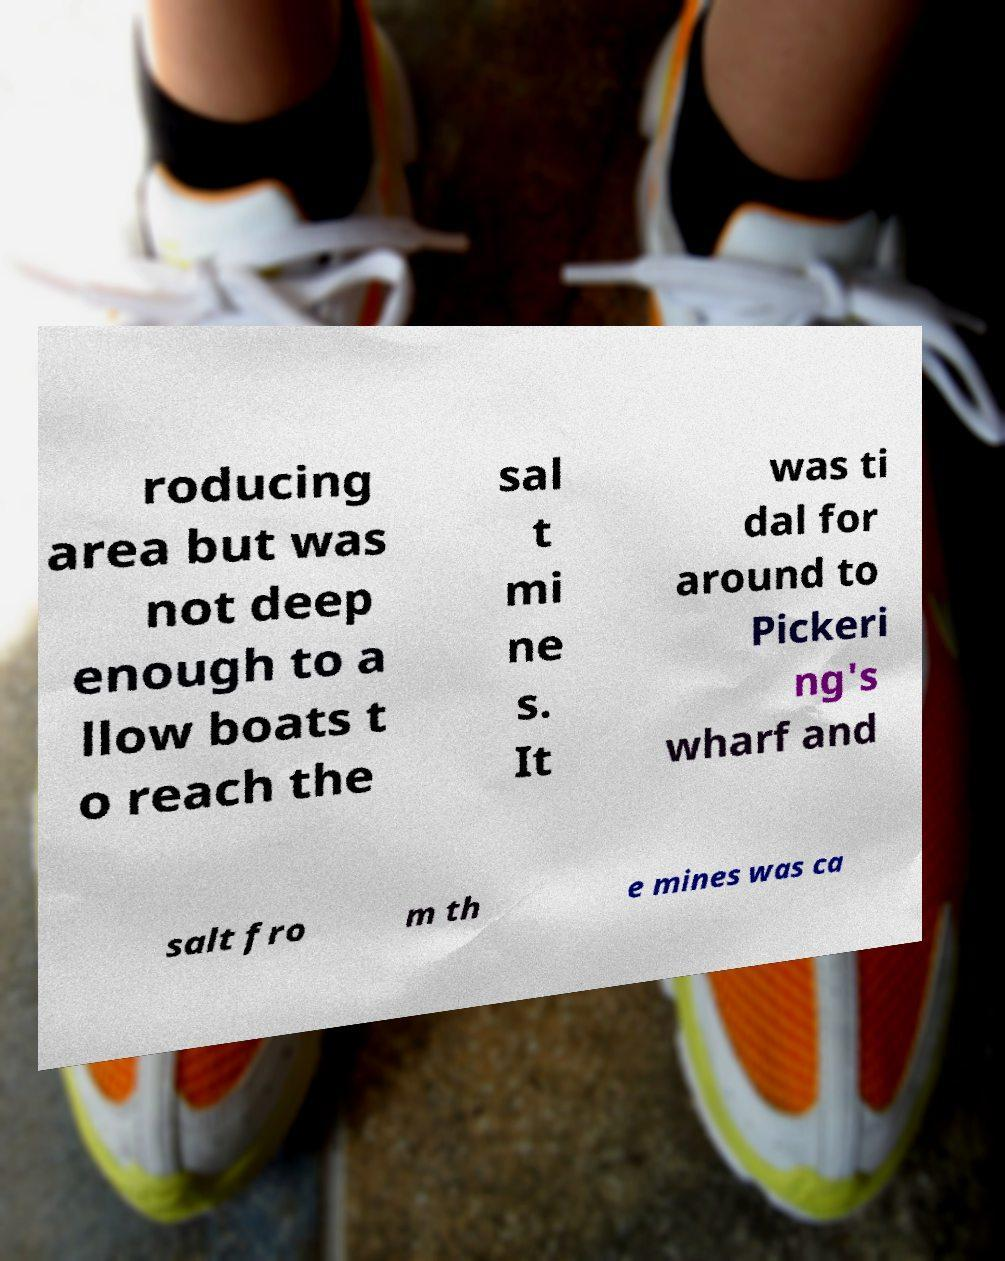There's text embedded in this image that I need extracted. Can you transcribe it verbatim? roducing area but was not deep enough to a llow boats t o reach the sal t mi ne s. It was ti dal for around to Pickeri ng's wharf and salt fro m th e mines was ca 